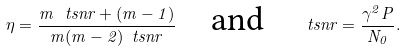<formula> <loc_0><loc_0><loc_500><loc_500>\eta = \frac { m \, \ t s n r + ( m - 1 ) } { m ( m - 2 ) \ t s n r } \quad \text {and} \quad \ t s n r = \frac { \gamma ^ { 2 } P } { N _ { 0 } } .</formula> 